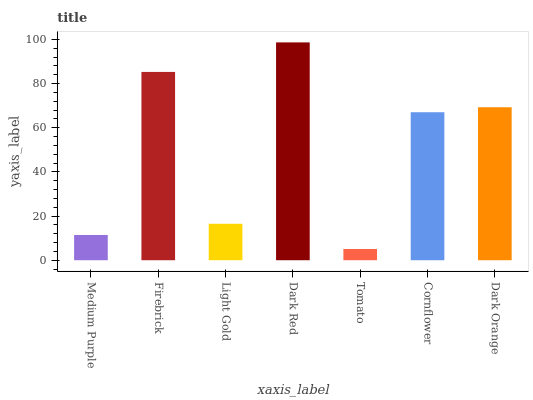Is Tomato the minimum?
Answer yes or no. Yes. Is Dark Red the maximum?
Answer yes or no. Yes. Is Firebrick the minimum?
Answer yes or no. No. Is Firebrick the maximum?
Answer yes or no. No. Is Firebrick greater than Medium Purple?
Answer yes or no. Yes. Is Medium Purple less than Firebrick?
Answer yes or no. Yes. Is Medium Purple greater than Firebrick?
Answer yes or no. No. Is Firebrick less than Medium Purple?
Answer yes or no. No. Is Cornflower the high median?
Answer yes or no. Yes. Is Cornflower the low median?
Answer yes or no. Yes. Is Dark Red the high median?
Answer yes or no. No. Is Medium Purple the low median?
Answer yes or no. No. 